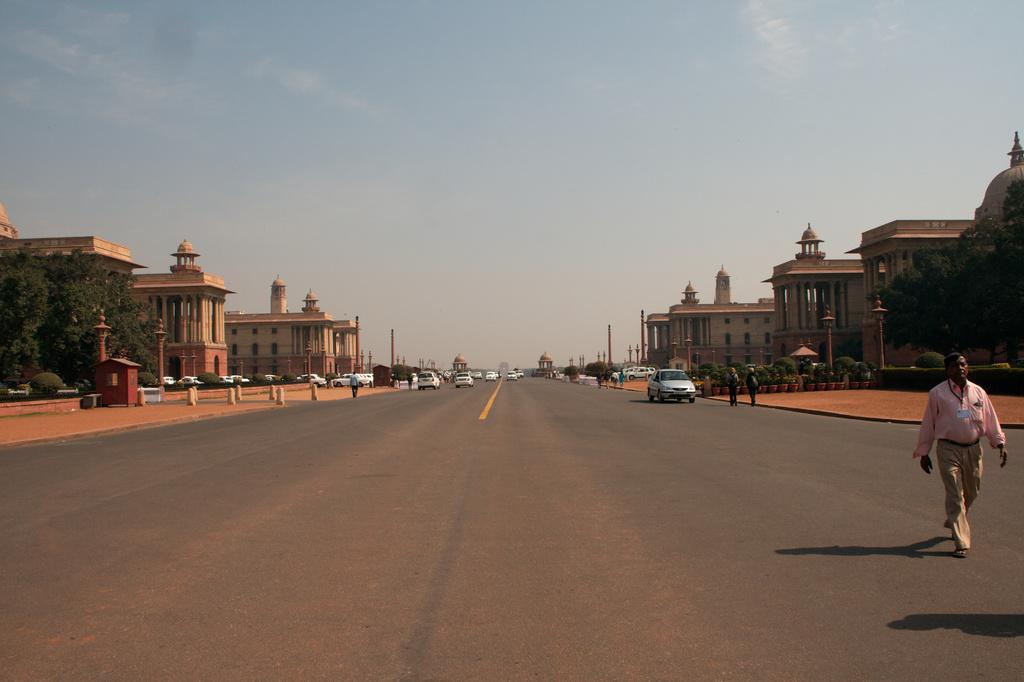Describe this image in one or two sentences. In this picture we can see few buildings, vehicles and group of people, on the left and right hand side of the image we can see few trees, in the background we can see few poles and clouds. 